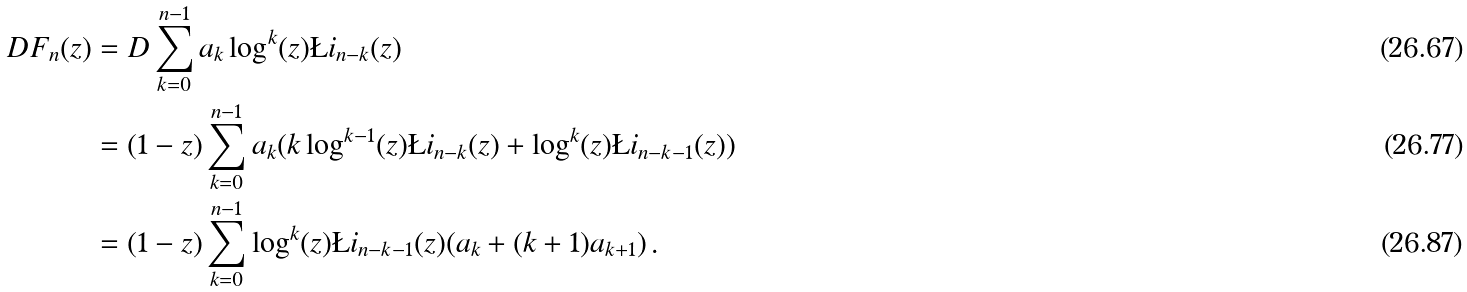<formula> <loc_0><loc_0><loc_500><loc_500>D F _ { n } ( z ) & = D \sum _ { k = 0 } ^ { n - 1 } a _ { k } \log ^ { k } ( z ) \L i _ { n - k } ( z ) \\ & = ( 1 - z ) \sum _ { k = 0 } ^ { n - 1 } a _ { k } ( k \log ^ { k - 1 } ( z ) \L i _ { n - k } ( z ) + \log ^ { k } ( z ) \L i _ { n - k - 1 } ( z ) ) \\ & = ( 1 - z ) \sum _ { k = 0 } ^ { n - 1 } \log ^ { k } ( z ) \L i _ { n - k - 1 } ( z ) ( a _ { k } + ( k + 1 ) a _ { k + 1 } ) \, .</formula> 